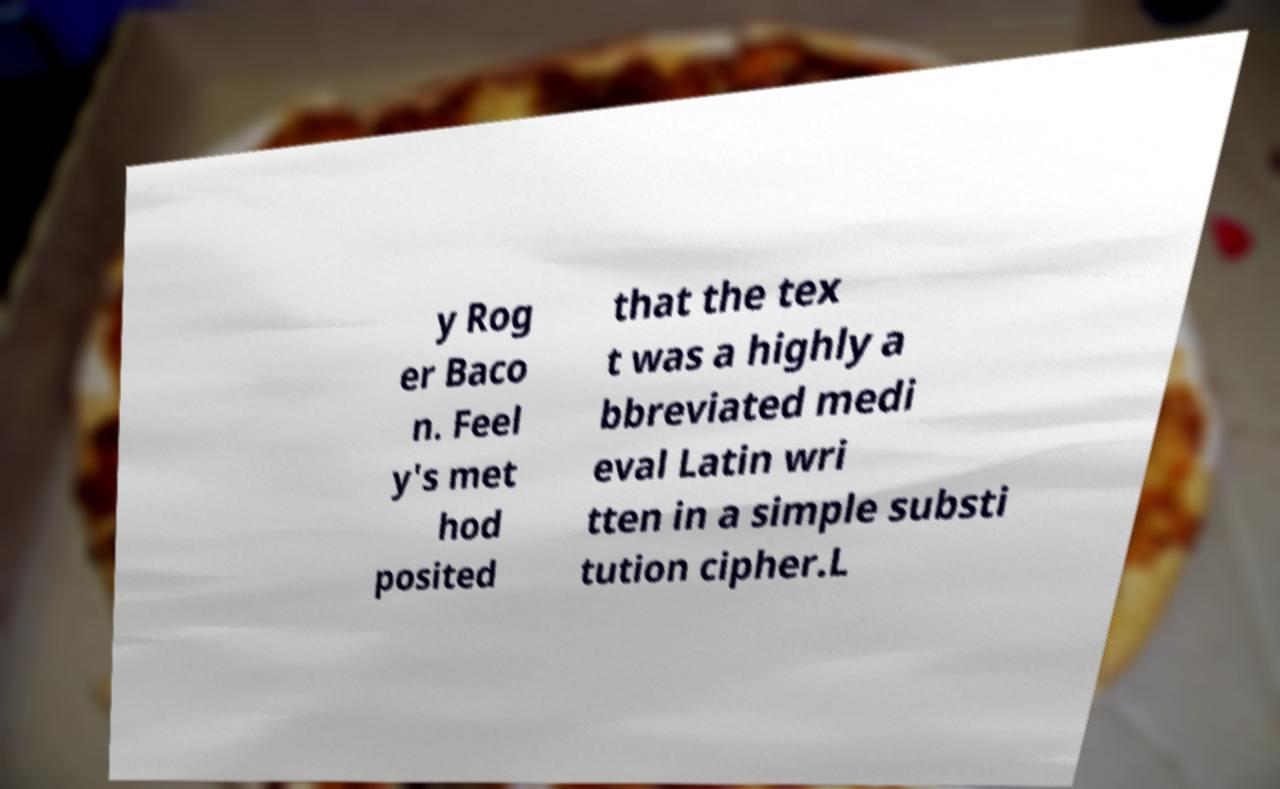What messages or text are displayed in this image? I need them in a readable, typed format. y Rog er Baco n. Feel y's met hod posited that the tex t was a highly a bbreviated medi eval Latin wri tten in a simple substi tution cipher.L 